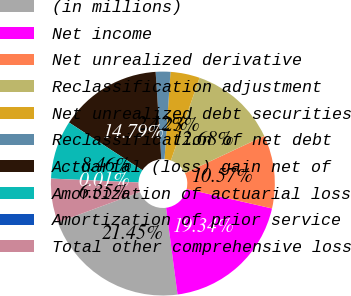<chart> <loc_0><loc_0><loc_500><loc_500><pie_chart><fcel>(in millions)<fcel>Net income<fcel>Net unrealized derivative<fcel>Reclassification adjustment<fcel>Net unrealized debt securities<fcel>Reclassification of net debt<fcel>Actuarial (loss) gain net of<fcel>Amortization of actuarial loss<fcel>Amortization of prior service<fcel>Total other comprehensive loss<nl><fcel>21.45%<fcel>19.34%<fcel>10.57%<fcel>12.68%<fcel>4.23%<fcel>2.12%<fcel>14.79%<fcel>8.46%<fcel>0.01%<fcel>6.35%<nl></chart> 